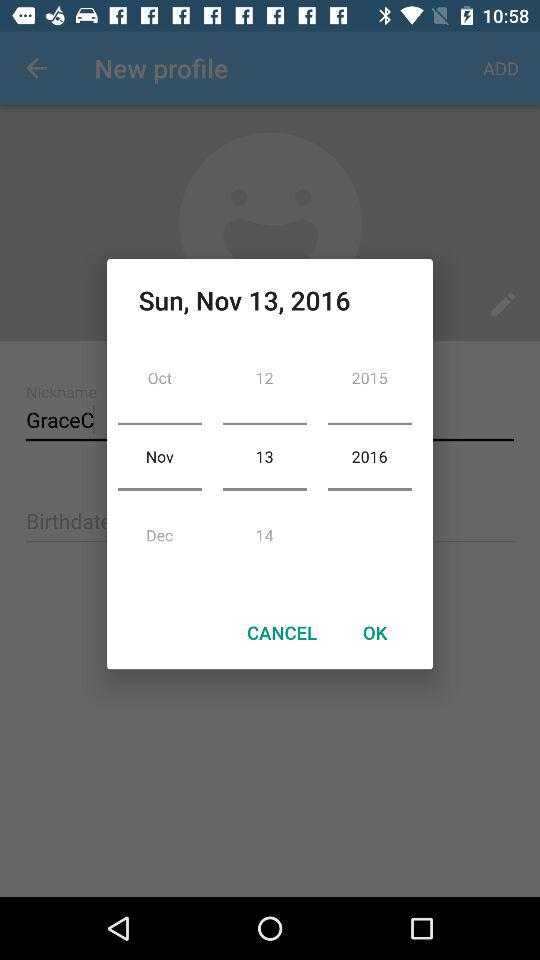How many years are included in the date range?
Answer the question using a single word or phrase. 2 